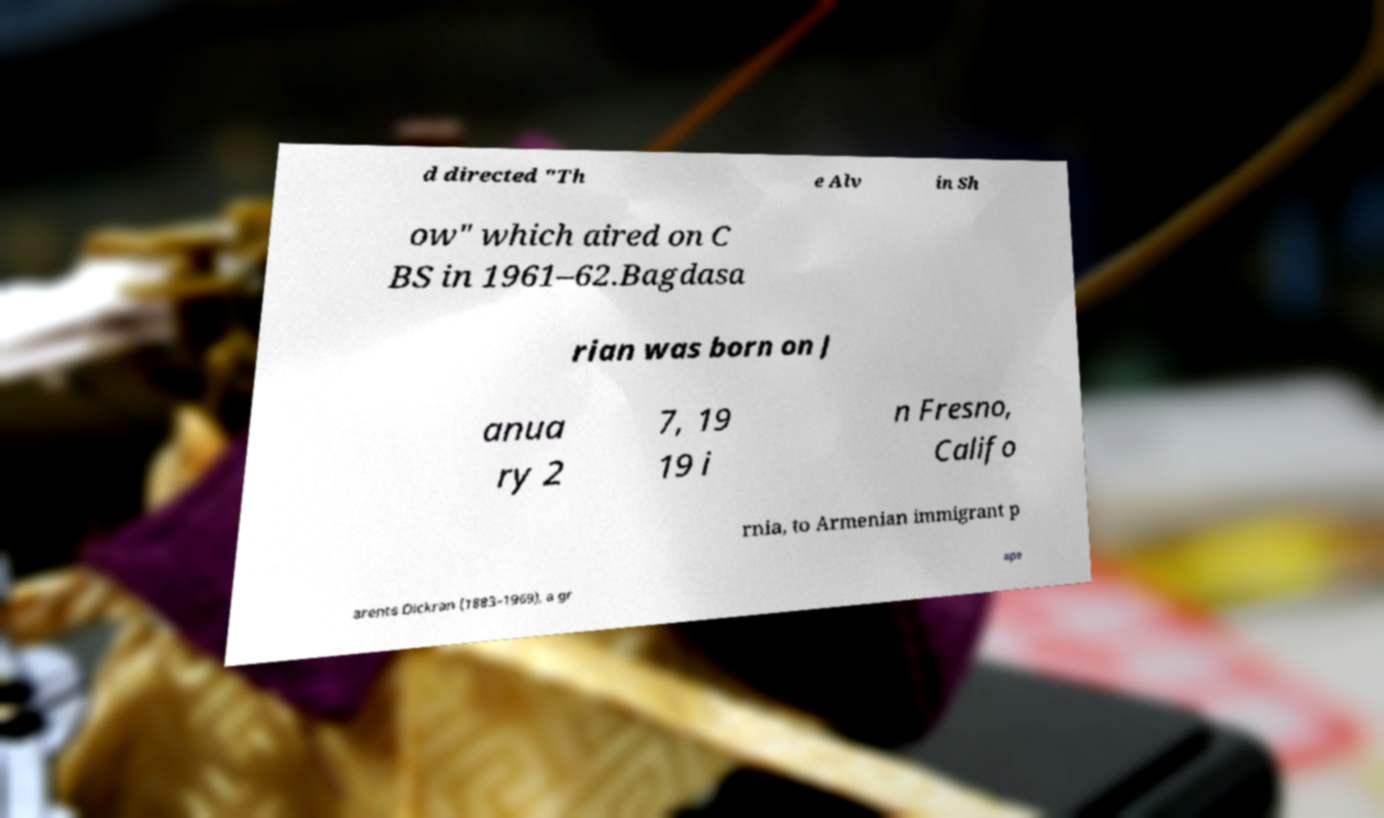There's text embedded in this image that I need extracted. Can you transcribe it verbatim? d directed "Th e Alv in Sh ow" which aired on C BS in 1961–62.Bagdasa rian was born on J anua ry 2 7, 19 19 i n Fresno, Califo rnia, to Armenian immigrant p arents Dickran (1883–1969), a gr ape 